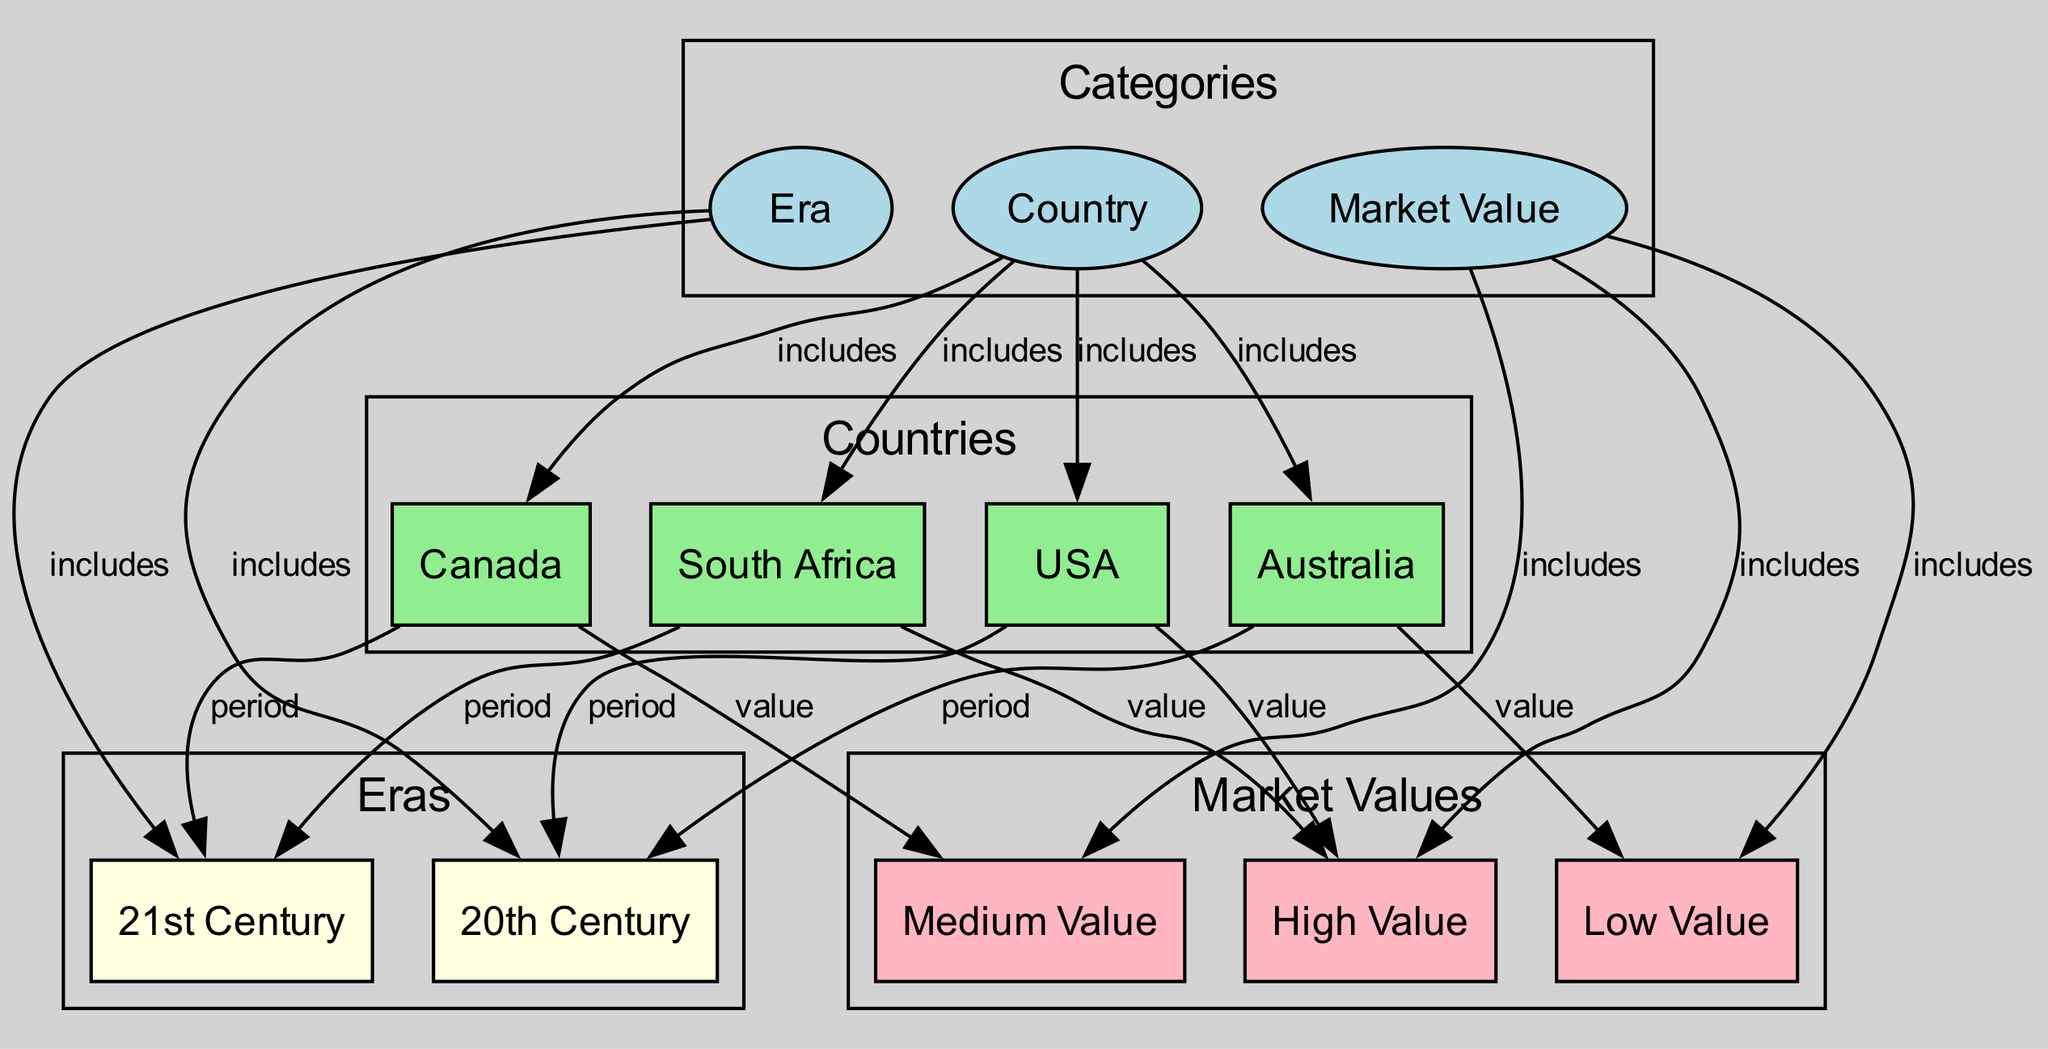What types of nodes are included in the diagram? The diagram includes three types of nodes: categories, countries, eras, and market values. The categories consist of "Country," "Era," and "Market Value." Each type of node is color-coded and categorized differently.
Answer: categories, countries, eras, market values How many countries are represented in the diagram? There are four countries listed in the diagram: USA, Canada, Australia, and South Africa. Each country is a unique node connected to the "Country" category node.
Answer: 4 Which country is associated with "High Value"? The USA and South Africa are both connected to the "High Value" node via edges labeled "value." Therefore, they are the countries associated with high market value coins.
Answer: USA, South Africa What era do Canadian coins belong to? The diagram shows that Canadian coins are associated with the 21st Century through an edge labeled "period." This connection indicates the era classification for Canadian bullion coins.
Answer: 21st Century Which market value category includes Australian coins? Australian coins are classified under "Low Value," as indicated by the edge labeled "value" that connects Australia to the Low Value node.
Answer: Low Value How many edges connect countries to market value categories? There are a total of four edges that connect countries to market value categories. These edges show the relationship between each country and its corresponding market value classification.
Answer: 4 Which countries have coins classified as "Medium Value"? According to the diagram, Canada has coins classified as "Medium Value," as indicated by the direct connection to the Medium Value node. There are no other countries connected to this category.
Answer: Canada What is the relationship between "Market Value" and "Era"? The "Market Value" and "Era" categories are different categories in the diagram. They do not have a direct relationship or connection to each other shown in the diagram; instead, they are connected to the "Country" category independently.
Answer: No direct relationship Which country has coins from the "20th Century"? The USA and Australia are linked to the "20th Century" era through edges labeled "period." This signifies that both countries have bullion coins minted during this particular time frame.
Answer: USA, Australia 